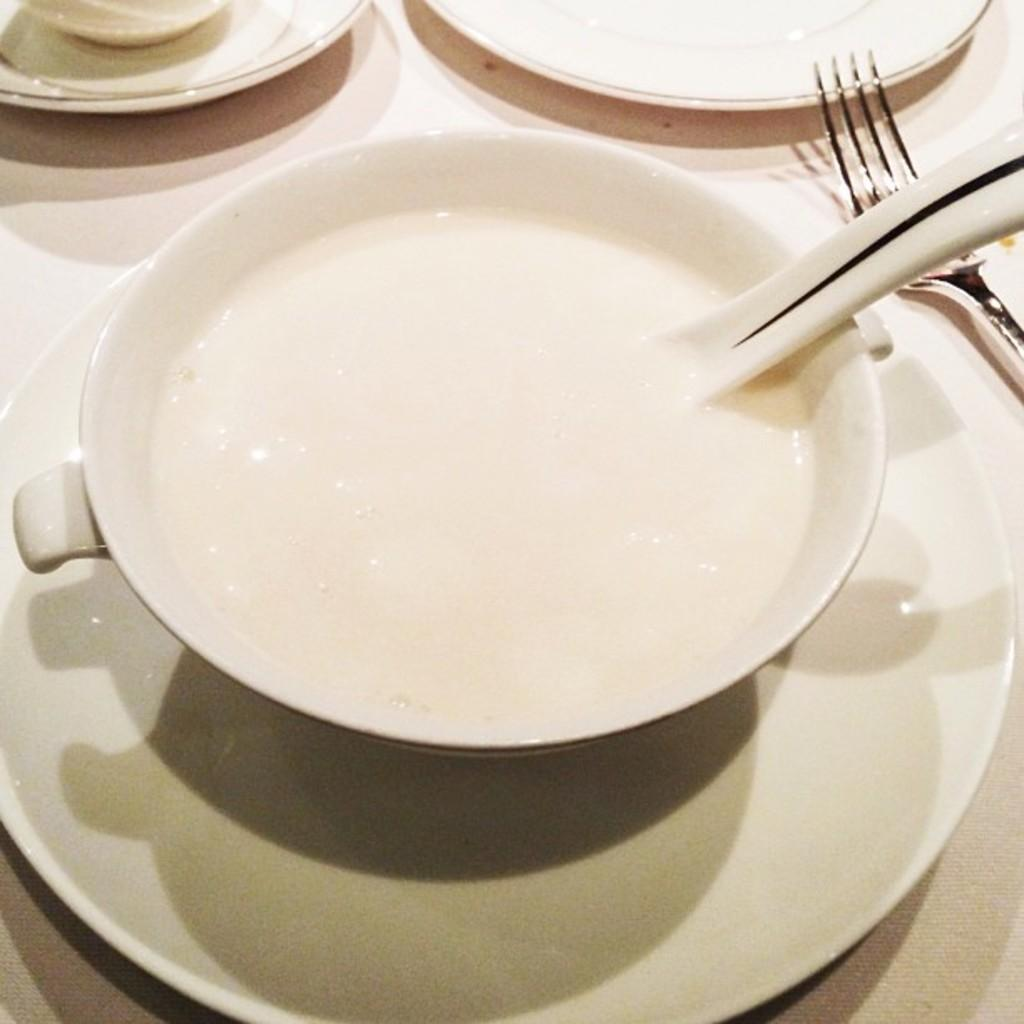What type of table is in the image? There is a white table in the image. What items are on the table? There are saucers, cups, a bowl, a spoon, and a fork on the table. How many items are on the table? There are six items on the table: saucers, cups, a bowl, a spoon, and a fork. What type of tin can be seen on the table in the image? There is no tin present on the table in the image. How many feet are visible on the table in the image? There are no feet visible on the table in the image. 